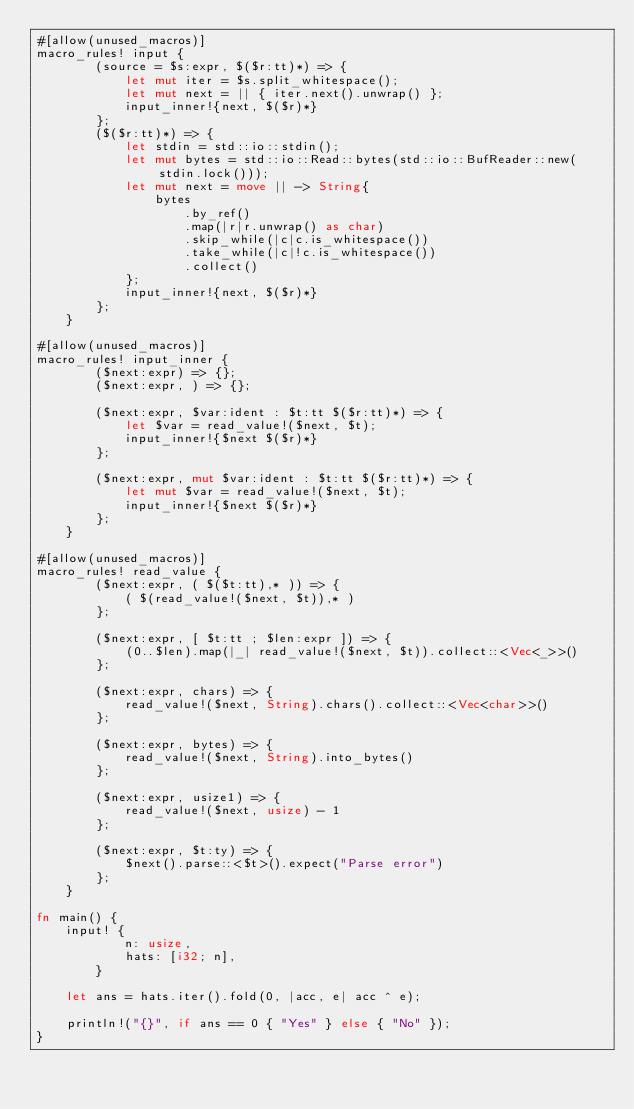<code> <loc_0><loc_0><loc_500><loc_500><_Rust_>#[allow(unused_macros)]
macro_rules! input {
        (source = $s:expr, $($r:tt)*) => {
            let mut iter = $s.split_whitespace();
            let mut next = || { iter.next().unwrap() };
            input_inner!{next, $($r)*}
        };
        ($($r:tt)*) => {
            let stdin = std::io::stdin();
            let mut bytes = std::io::Read::bytes(std::io::BufReader::new(stdin.lock()));
            let mut next = move || -> String{
                bytes
                    .by_ref()
                    .map(|r|r.unwrap() as char)
                    .skip_while(|c|c.is_whitespace())
                    .take_while(|c|!c.is_whitespace())
                    .collect()
            };
            input_inner!{next, $($r)*}
        };
    }

#[allow(unused_macros)]
macro_rules! input_inner {
        ($next:expr) => {};
        ($next:expr, ) => {};
     
        ($next:expr, $var:ident : $t:tt $($r:tt)*) => {
            let $var = read_value!($next, $t);
            input_inner!{$next $($r)*}
        };
     
        ($next:expr, mut $var:ident : $t:tt $($r:tt)*) => {
            let mut $var = read_value!($next, $t);
            input_inner!{$next $($r)*}
        };
    }

#[allow(unused_macros)]
macro_rules! read_value {
        ($next:expr, ( $($t:tt),* )) => {
            ( $(read_value!($next, $t)),* )
        };
     
        ($next:expr, [ $t:tt ; $len:expr ]) => {
            (0..$len).map(|_| read_value!($next, $t)).collect::<Vec<_>>()
        };
     
        ($next:expr, chars) => {
            read_value!($next, String).chars().collect::<Vec<char>>()
        };
     
        ($next:expr, bytes) => {
            read_value!($next, String).into_bytes()
        };
     
        ($next:expr, usize1) => {
            read_value!($next, usize) - 1
        };
     
        ($next:expr, $t:ty) => {
            $next().parse::<$t>().expect("Parse error")
        };
    }

fn main() {
    input! {
            n: usize,
            hats: [i32; n],
        }

    let ans = hats.iter().fold(0, |acc, e| acc ^ e);

    println!("{}", if ans == 0 { "Yes" } else { "No" });
}</code> 